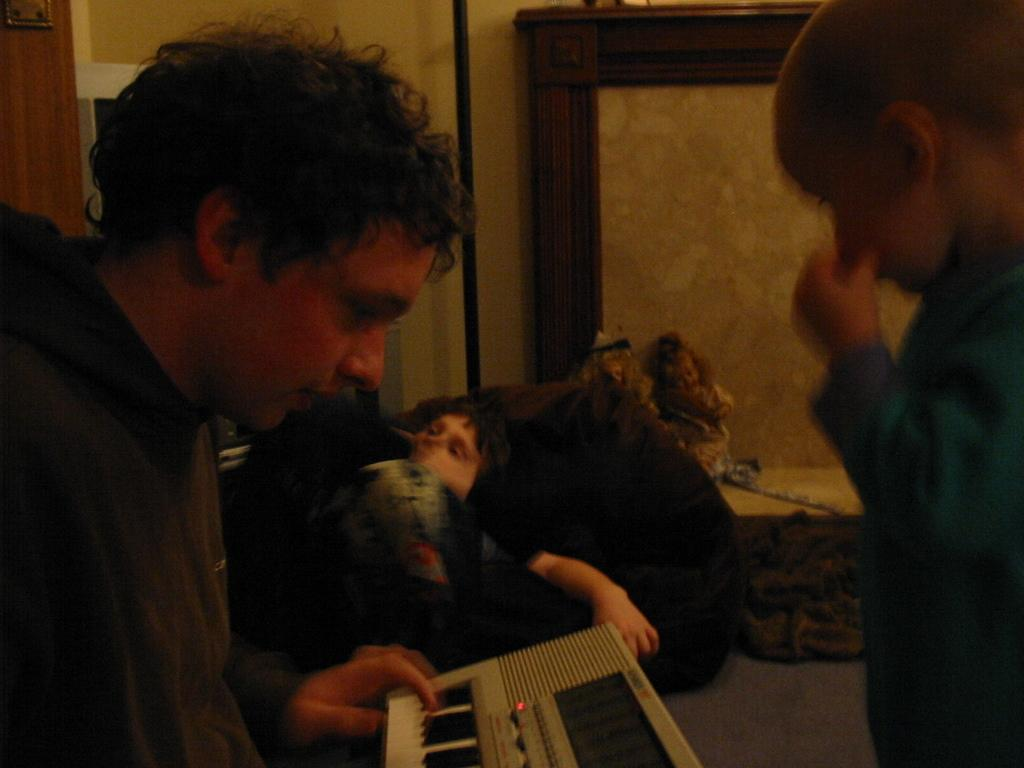What is the person in the image wearing? The person is wearing a hoodie in the image. What activity is the person engaged in? The person is playing a piano. Can you describe the presence of another person in the image? There is a kid on the right side of the image. What can be seen in the background of the image? There are dolls and a wall in the background of the image. What type of lunch is being served in the image? There is no lunch present in the image; it features a person playing a piano, a kid, dolls, and a wall in the background. 